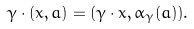Convert formula to latex. <formula><loc_0><loc_0><loc_500><loc_500>\gamma \cdot ( x , a ) = ( \gamma \cdot x , \alpha _ { \gamma } ( a ) ) .</formula> 